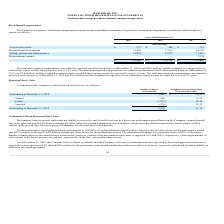According to Maxlinear's financial document, What is the eligibility of Performance-based restricted stock to vest? at the end of each fiscal year in a three-year performance period based on the Company’s annual growth rate. The document states: "based restricted stock units are eligible to vest at the end of each fiscal year in a three-year performance period based on the Company’s annual grow..." Also, What was the number of shares Outstanding at December 31, 2018? According to the financial document, 3,263 (in thousands). The relevant text states: "Outstanding at December 31, 2018 3,263 $ 20.23..." Also, What was the number of shares granted in 2019? According to the financial document, 1,580 (in thousands). The relevant text states: "Granted 1,580 23.23..." Also, can you calculate: What was the change in the outstanding from 2018 to 2019? Based on the calculation: 2,924 - 3,263, the result is -339 (in thousands). This is based on the information: "Outstanding at December 31, 2019 2,924 21.72 Outstanding at December 31, 2018 3,263 $ 20.23..." The key data points involved are: 2,924, 3,263. Also, can you calculate: What percentage of outstanding at 2019 was granted? Based on the calculation: 1,580 / 2,924, the result is 54.04 (percentage). This is based on the information: "Outstanding at December 31, 2019 2,924 21.72 Granted 1,580 23.23..." The key data points involved are: 1,580, 2,924. Also, can you calculate: What is the average vested and canceled in 2019? To answer this question, I need to perform calculations using the financial data. The calculation is: -(1,541 + 378) / 2, which equals -959.5 (in thousands). This is based on the information: "Vested (1,541) 20.16 Canceled (378 ) 21.52..." The key data points involved are: 1,541, 378. 